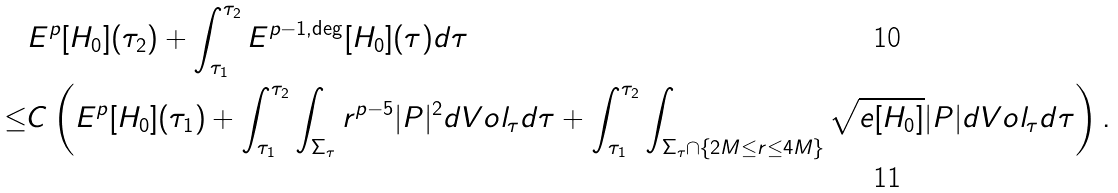Convert formula to latex. <formula><loc_0><loc_0><loc_500><loc_500>& E ^ { p } [ H _ { 0 } ] ( \tau _ { 2 } ) + \int _ { \tau _ { 1 } } ^ { \tau _ { 2 } } E ^ { p - 1 , \deg } [ H _ { 0 } ] ( \tau ) d \tau \\ \leq & C \left ( E ^ { p } [ H _ { 0 } ] ( \tau _ { 1 } ) + \int _ { \tau _ { 1 } } ^ { \tau _ { 2 } } \int _ { \Sigma _ { \tau } } r ^ { p - 5 } | P | ^ { 2 } d V o l _ { \tau } d \tau + \int _ { \tau _ { 1 } } ^ { \tau _ { 2 } } \int _ { \Sigma _ { \tau } \cap \{ 2 M \leq r \leq 4 M \} } \sqrt { e [ H _ { 0 } ] } | P | d V o l _ { \tau } d \tau \right ) .</formula> 